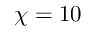<formula> <loc_0><loc_0><loc_500><loc_500>\chi = 1 0</formula> 